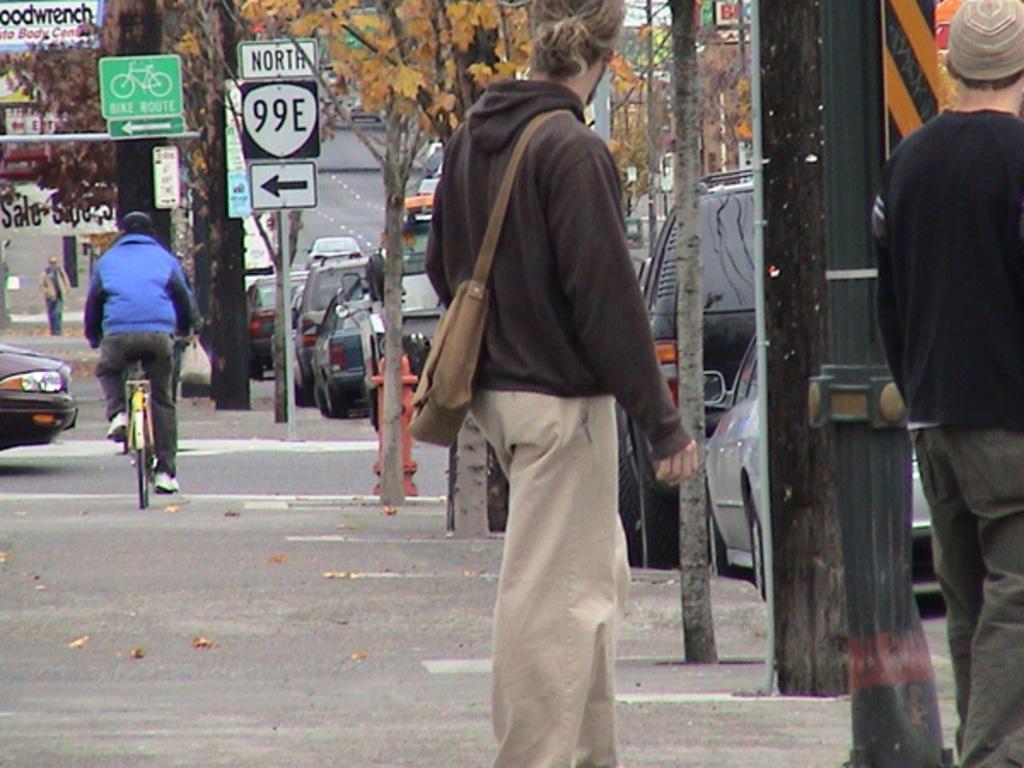How would you summarize this image in a sentence or two? In this picture there is a person standing wearing a hat, there is another person wearing a hat. A person is riding the bicycle , and there are few vehicles parked at the side of the road. 